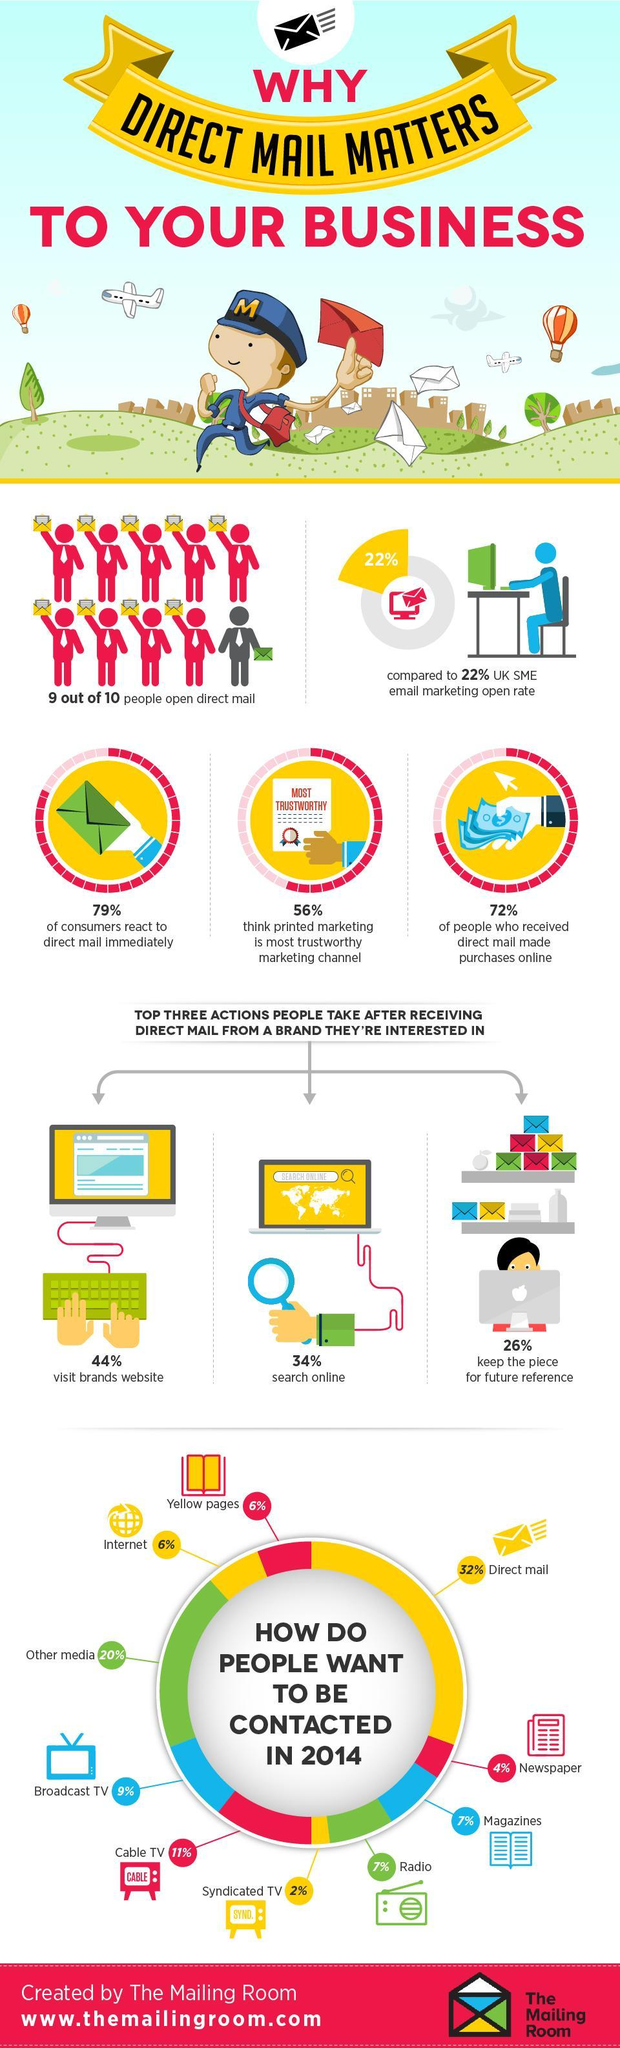What percent of the people visit brands website after receiving direct mail from a brand they are interested in?
Answer the question with a short phrase. 44% What percentage of people want to be contacted through the newspaper in 2014? 4% How do the majority of people want to be contacted in 2014? Direct mail What percent of the people think that printed marketing is most trustworthy marketing channel? 56% What percentage of people want to be contacted through the internet in 2014? 6% What percent of the people search online after receiving direct mail from a brand they are interested in? 34% 